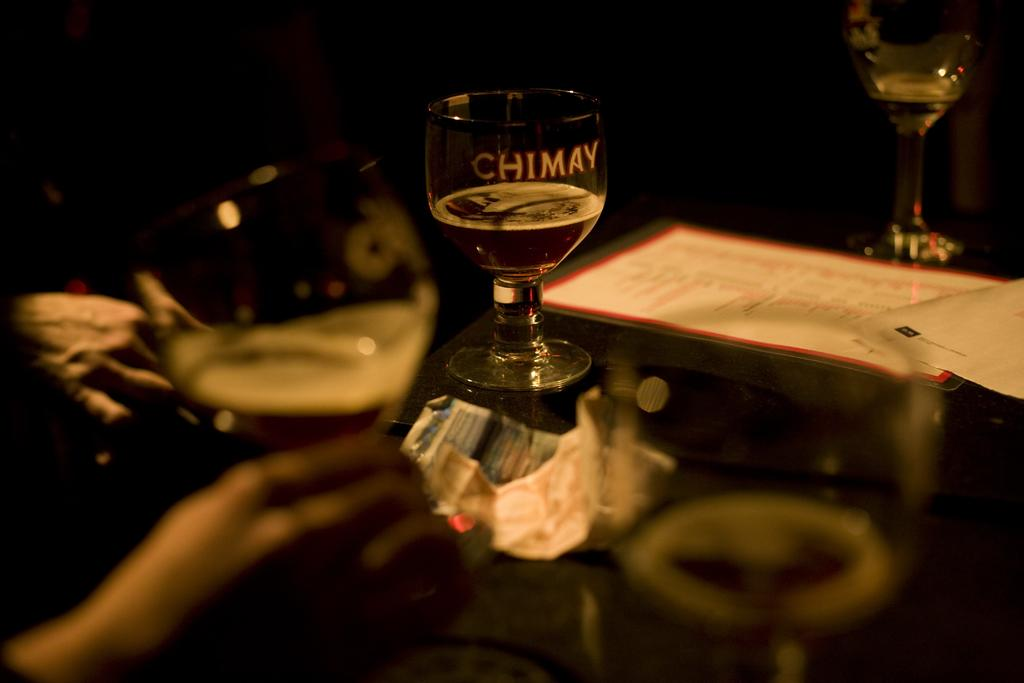What object is on the table in the image? There is a glass on a table in the image. What is on top of the glass? There is paper on the glass. Who is holding the glass in the image? A person is holding the glass in the image. What is inside the glass? There is liquid in the glass. How would you describe the lighting in the image? The environment is dark. What type of quilt is being used to cover the icicle in the image? There is no quilt or icicle present in the image. 